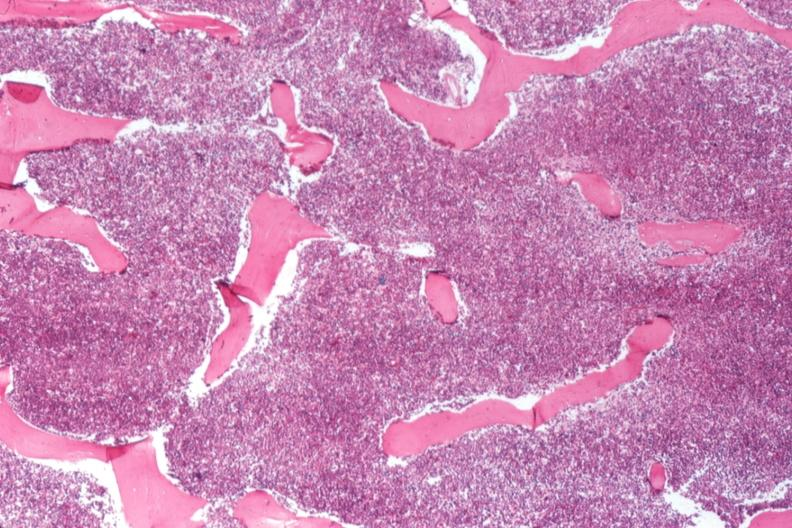how many % does this image show cellular marrow?
Answer the question using a single word or phrase. 100 